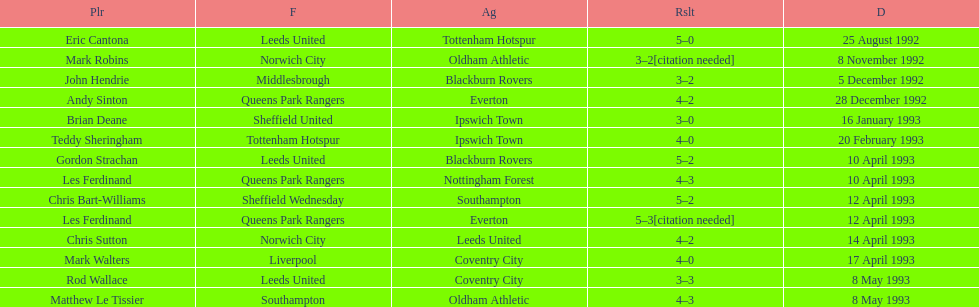Would you be able to parse every entry in this table? {'header': ['Plr', 'F', 'Ag', 'Rslt', 'D'], 'rows': [['Eric Cantona', 'Leeds United', 'Tottenham Hotspur', '5–0', '25 August 1992'], ['Mark Robins', 'Norwich City', 'Oldham Athletic', '3–2[citation needed]', '8 November 1992'], ['John Hendrie', 'Middlesbrough', 'Blackburn Rovers', '3–2', '5 December 1992'], ['Andy Sinton', 'Queens Park Rangers', 'Everton', '4–2', '28 December 1992'], ['Brian Deane', 'Sheffield United', 'Ipswich Town', '3–0', '16 January 1993'], ['Teddy Sheringham', 'Tottenham Hotspur', 'Ipswich Town', '4–0', '20 February 1993'], ['Gordon Strachan', 'Leeds United', 'Blackburn Rovers', '5–2', '10 April 1993'], ['Les Ferdinand', 'Queens Park Rangers', 'Nottingham Forest', '4–3', '10 April 1993'], ['Chris Bart-Williams', 'Sheffield Wednesday', 'Southampton', '5–2', '12 April 1993'], ['Les Ferdinand', 'Queens Park Rangers', 'Everton', '5–3[citation needed]', '12 April 1993'], ['Chris Sutton', 'Norwich City', 'Leeds United', '4–2', '14 April 1993'], ['Mark Walters', 'Liverpool', 'Coventry City', '4–0', '17 April 1993'], ['Rod Wallace', 'Leeds United', 'Coventry City', '3–3', '8 May 1993'], ['Matthew Le Tissier', 'Southampton', 'Oldham Athletic', '4–3', '8 May 1993']]} In the 1992-1993 premier league, what was the total number of hat tricks scored by all players? 14. 